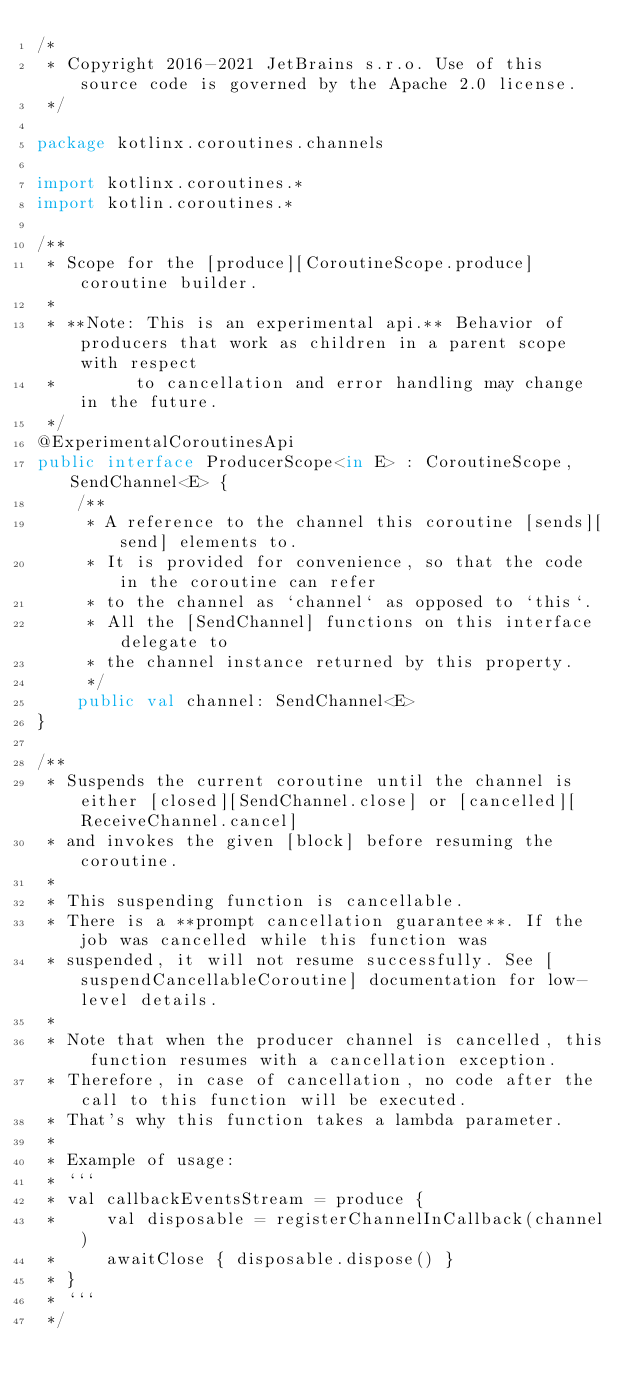<code> <loc_0><loc_0><loc_500><loc_500><_Kotlin_>/*
 * Copyright 2016-2021 JetBrains s.r.o. Use of this source code is governed by the Apache 2.0 license.
 */

package kotlinx.coroutines.channels

import kotlinx.coroutines.*
import kotlin.coroutines.*

/**
 * Scope for the [produce][CoroutineScope.produce] coroutine builder.
 *
 * **Note: This is an experimental api.** Behavior of producers that work as children in a parent scope with respect
 *        to cancellation and error handling may change in the future.
 */
@ExperimentalCoroutinesApi
public interface ProducerScope<in E> : CoroutineScope, SendChannel<E> {
    /**
     * A reference to the channel this coroutine [sends][send] elements to.
     * It is provided for convenience, so that the code in the coroutine can refer
     * to the channel as `channel` as opposed to `this`.
     * All the [SendChannel] functions on this interface delegate to
     * the channel instance returned by this property.
     */
    public val channel: SendChannel<E>
}

/**
 * Suspends the current coroutine until the channel is either [closed][SendChannel.close] or [cancelled][ReceiveChannel.cancel]
 * and invokes the given [block] before resuming the coroutine.
 *
 * This suspending function is cancellable.
 * There is a **prompt cancellation guarantee**. If the job was cancelled while this function was
 * suspended, it will not resume successfully. See [suspendCancellableCoroutine] documentation for low-level details.
 *
 * Note that when the producer channel is cancelled, this function resumes with a cancellation exception.
 * Therefore, in case of cancellation, no code after the call to this function will be executed.
 * That's why this function takes a lambda parameter.
 *
 * Example of usage:
 * ```
 * val callbackEventsStream = produce {
 *     val disposable = registerChannelInCallback(channel)
 *     awaitClose { disposable.dispose() }
 * }
 * ```
 */</code> 